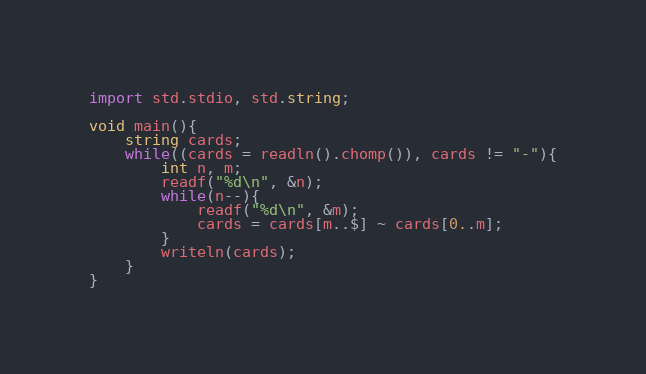Convert code to text. <code><loc_0><loc_0><loc_500><loc_500><_D_>import std.stdio, std.string;

void main(){
	string cards;
	while((cards = readln().chomp()), cards != "-"){
		int n, m;
		readf("%d\n", &n);
		while(n--){
			readf("%d\n", &m);
			cards = cards[m..$] ~ cards[0..m];
		}
		writeln(cards);
	}
}</code> 